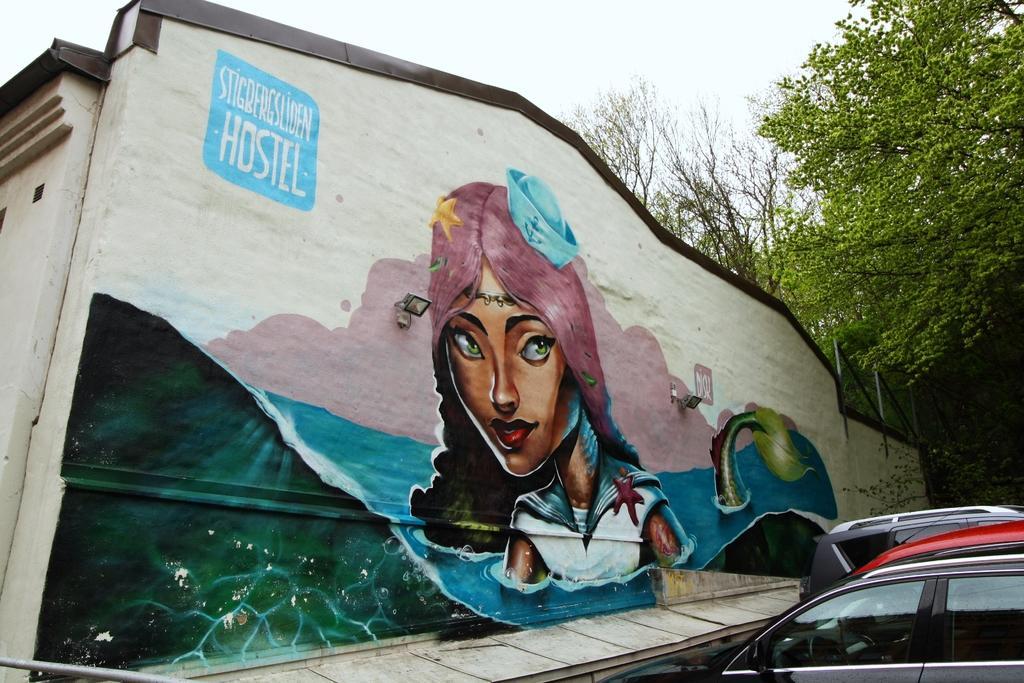Can you describe this image briefly? In this image I can see the painting to the wall. I can see the painting to the wall. I can see the painting of the woman in the air. The woman is wearing the white and blue color and the water are in blue color. To the side of the wall I can see few vehicles. In the background there are trees and the wall. 